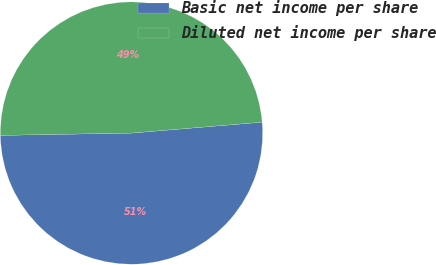Convert chart to OTSL. <chart><loc_0><loc_0><loc_500><loc_500><pie_chart><fcel>Basic net income per share<fcel>Diluted net income per share<nl><fcel>51.05%<fcel>48.95%<nl></chart> 